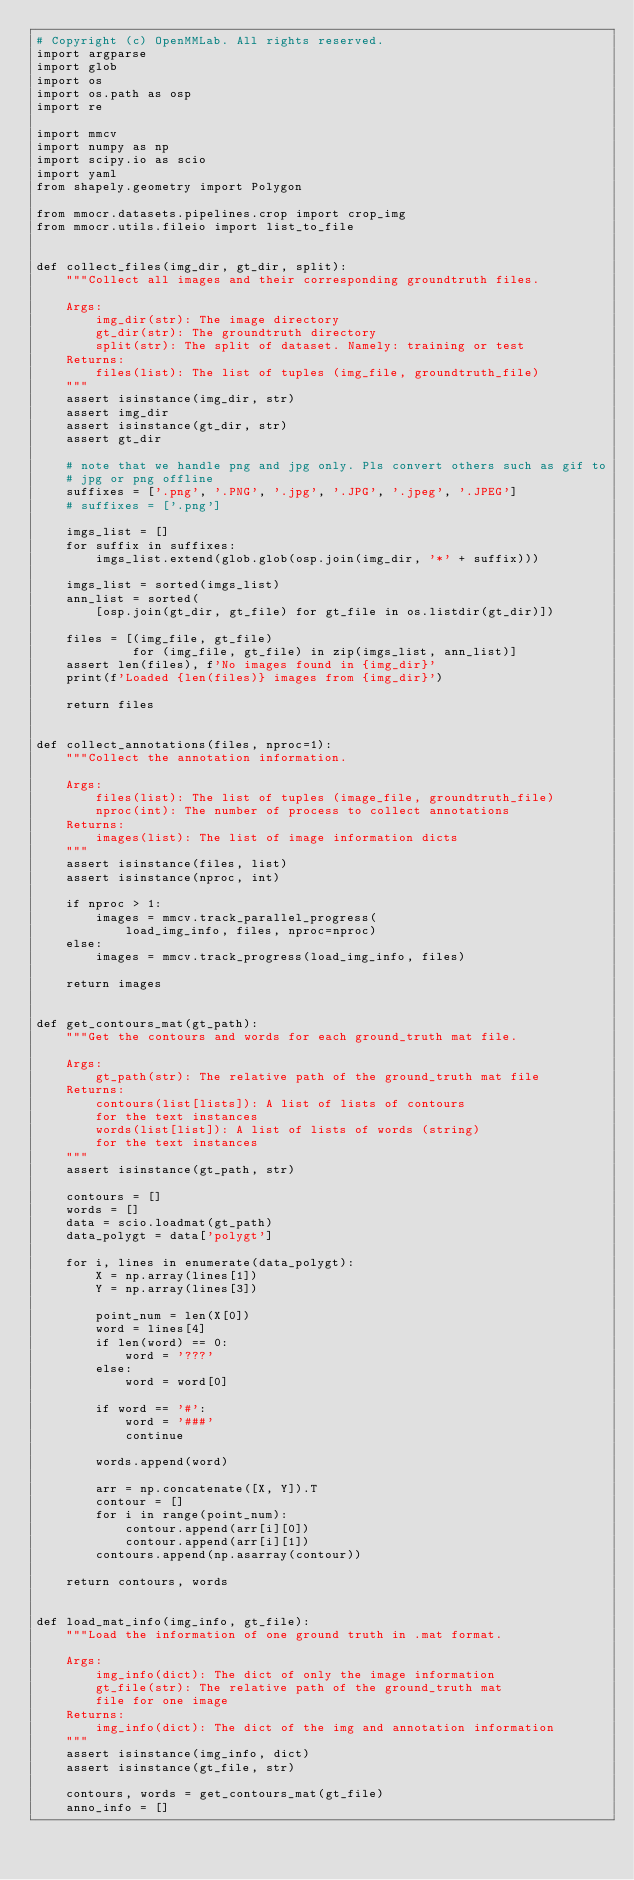Convert code to text. <code><loc_0><loc_0><loc_500><loc_500><_Python_># Copyright (c) OpenMMLab. All rights reserved.
import argparse
import glob
import os
import os.path as osp
import re

import mmcv
import numpy as np
import scipy.io as scio
import yaml
from shapely.geometry import Polygon

from mmocr.datasets.pipelines.crop import crop_img
from mmocr.utils.fileio import list_to_file


def collect_files(img_dir, gt_dir, split):
    """Collect all images and their corresponding groundtruth files.

    Args:
        img_dir(str): The image directory
        gt_dir(str): The groundtruth directory
        split(str): The split of dataset. Namely: training or test
    Returns:
        files(list): The list of tuples (img_file, groundtruth_file)
    """
    assert isinstance(img_dir, str)
    assert img_dir
    assert isinstance(gt_dir, str)
    assert gt_dir

    # note that we handle png and jpg only. Pls convert others such as gif to
    # jpg or png offline
    suffixes = ['.png', '.PNG', '.jpg', '.JPG', '.jpeg', '.JPEG']
    # suffixes = ['.png']

    imgs_list = []
    for suffix in suffixes:
        imgs_list.extend(glob.glob(osp.join(img_dir, '*' + suffix)))

    imgs_list = sorted(imgs_list)
    ann_list = sorted(
        [osp.join(gt_dir, gt_file) for gt_file in os.listdir(gt_dir)])

    files = [(img_file, gt_file)
             for (img_file, gt_file) in zip(imgs_list, ann_list)]
    assert len(files), f'No images found in {img_dir}'
    print(f'Loaded {len(files)} images from {img_dir}')

    return files


def collect_annotations(files, nproc=1):
    """Collect the annotation information.

    Args:
        files(list): The list of tuples (image_file, groundtruth_file)
        nproc(int): The number of process to collect annotations
    Returns:
        images(list): The list of image information dicts
    """
    assert isinstance(files, list)
    assert isinstance(nproc, int)

    if nproc > 1:
        images = mmcv.track_parallel_progress(
            load_img_info, files, nproc=nproc)
    else:
        images = mmcv.track_progress(load_img_info, files)

    return images


def get_contours_mat(gt_path):
    """Get the contours and words for each ground_truth mat file.

    Args:
        gt_path(str): The relative path of the ground_truth mat file
    Returns:
        contours(list[lists]): A list of lists of contours
        for the text instances
        words(list[list]): A list of lists of words (string)
        for the text instances
    """
    assert isinstance(gt_path, str)

    contours = []
    words = []
    data = scio.loadmat(gt_path)
    data_polygt = data['polygt']

    for i, lines in enumerate(data_polygt):
        X = np.array(lines[1])
        Y = np.array(lines[3])

        point_num = len(X[0])
        word = lines[4]
        if len(word) == 0:
            word = '???'
        else:
            word = word[0]

        if word == '#':
            word = '###'
            continue

        words.append(word)

        arr = np.concatenate([X, Y]).T
        contour = []
        for i in range(point_num):
            contour.append(arr[i][0])
            contour.append(arr[i][1])
        contours.append(np.asarray(contour))

    return contours, words


def load_mat_info(img_info, gt_file):
    """Load the information of one ground truth in .mat format.

    Args:
        img_info(dict): The dict of only the image information
        gt_file(str): The relative path of the ground_truth mat
        file for one image
    Returns:
        img_info(dict): The dict of the img and annotation information
    """
    assert isinstance(img_info, dict)
    assert isinstance(gt_file, str)

    contours, words = get_contours_mat(gt_file)
    anno_info = []</code> 